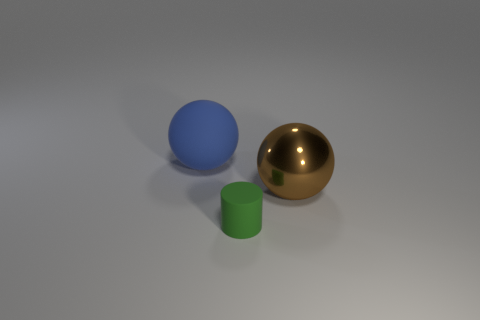Subtract all brown spheres. How many spheres are left? 1 Add 3 green metal balls. How many objects exist? 6 Add 1 metallic things. How many metallic things are left? 2 Add 2 small cylinders. How many small cylinders exist? 3 Subtract 0 red cylinders. How many objects are left? 3 Subtract all cylinders. How many objects are left? 2 Subtract all blue spheres. Subtract all green blocks. How many spheres are left? 1 Subtract all gray rubber blocks. Subtract all blue rubber spheres. How many objects are left? 2 